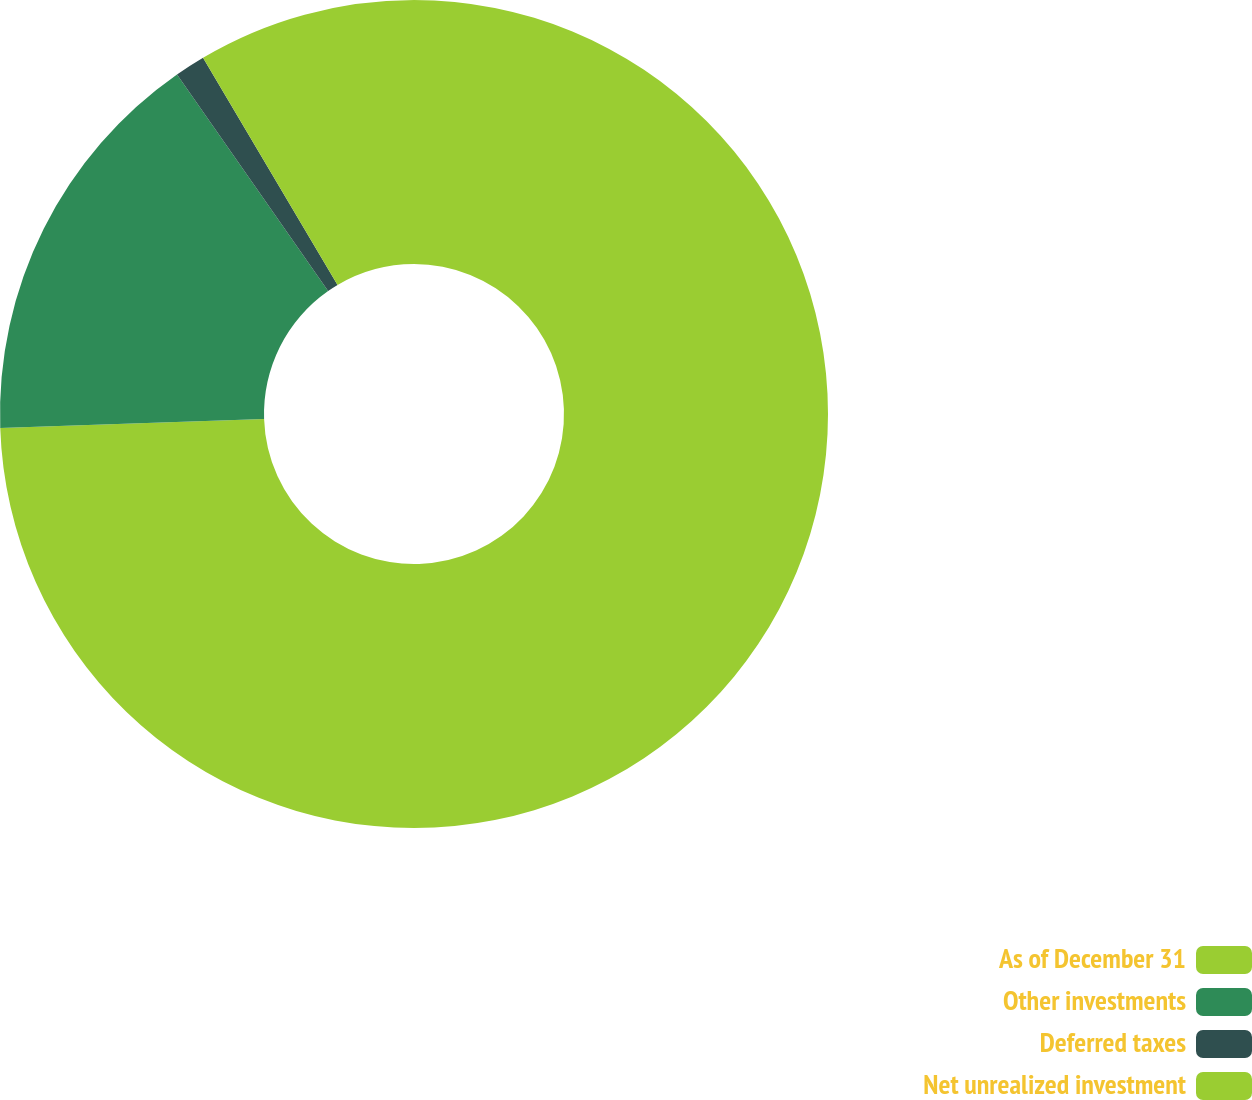Convert chart. <chart><loc_0><loc_0><loc_500><loc_500><pie_chart><fcel>As of December 31<fcel>Other investments<fcel>Deferred taxes<fcel>Net unrealized investment<nl><fcel>74.46%<fcel>15.84%<fcel>1.19%<fcel>8.51%<nl></chart> 